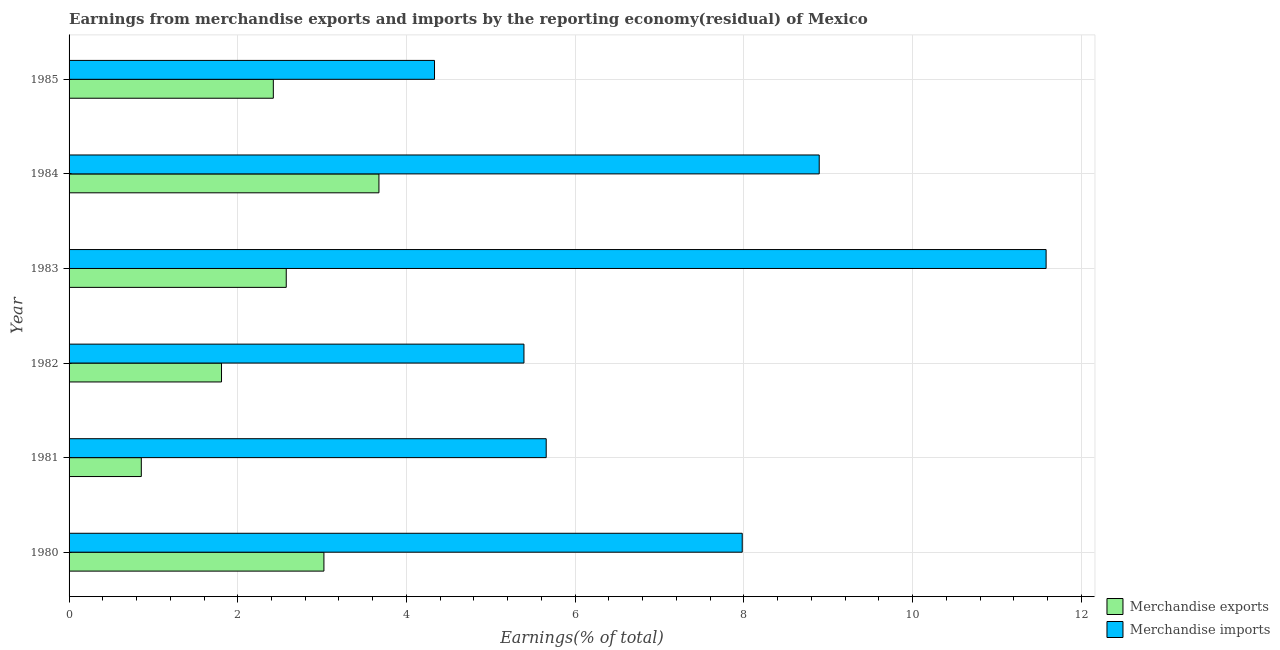How many different coloured bars are there?
Your answer should be very brief. 2. Are the number of bars on each tick of the Y-axis equal?
Make the answer very short. Yes. How many bars are there on the 6th tick from the top?
Give a very brief answer. 2. In how many cases, is the number of bars for a given year not equal to the number of legend labels?
Your answer should be very brief. 0. What is the earnings from merchandise imports in 1980?
Give a very brief answer. 7.98. Across all years, what is the maximum earnings from merchandise imports?
Your answer should be very brief. 11.58. Across all years, what is the minimum earnings from merchandise exports?
Ensure brevity in your answer.  0.86. In which year was the earnings from merchandise imports maximum?
Your answer should be very brief. 1983. What is the total earnings from merchandise exports in the graph?
Provide a succinct answer. 14.36. What is the difference between the earnings from merchandise imports in 1982 and that in 1984?
Your answer should be very brief. -3.5. What is the difference between the earnings from merchandise imports in 1984 and the earnings from merchandise exports in 1983?
Your answer should be compact. 6.32. What is the average earnings from merchandise exports per year?
Offer a very short reply. 2.39. In the year 1983, what is the difference between the earnings from merchandise exports and earnings from merchandise imports?
Your answer should be compact. -9.01. In how many years, is the earnings from merchandise exports greater than 5.2 %?
Ensure brevity in your answer.  0. What is the ratio of the earnings from merchandise imports in 1984 to that in 1985?
Offer a very short reply. 2.05. What is the difference between the highest and the second highest earnings from merchandise exports?
Make the answer very short. 0.65. What is the difference between the highest and the lowest earnings from merchandise exports?
Offer a terse response. 2.82. What does the 2nd bar from the top in 1982 represents?
Offer a very short reply. Merchandise exports. What does the 2nd bar from the bottom in 1984 represents?
Offer a terse response. Merchandise imports. How many bars are there?
Give a very brief answer. 12. Are all the bars in the graph horizontal?
Offer a very short reply. Yes. What is the difference between two consecutive major ticks on the X-axis?
Provide a succinct answer. 2. Are the values on the major ticks of X-axis written in scientific E-notation?
Ensure brevity in your answer.  No. Does the graph contain grids?
Your answer should be very brief. Yes. How are the legend labels stacked?
Make the answer very short. Vertical. What is the title of the graph?
Offer a terse response. Earnings from merchandise exports and imports by the reporting economy(residual) of Mexico. Does "Urban Population" appear as one of the legend labels in the graph?
Your response must be concise. No. What is the label or title of the X-axis?
Ensure brevity in your answer.  Earnings(% of total). What is the label or title of the Y-axis?
Your response must be concise. Year. What is the Earnings(% of total) of Merchandise exports in 1980?
Make the answer very short. 3.02. What is the Earnings(% of total) in Merchandise imports in 1980?
Offer a very short reply. 7.98. What is the Earnings(% of total) in Merchandise exports in 1981?
Give a very brief answer. 0.86. What is the Earnings(% of total) in Merchandise imports in 1981?
Provide a succinct answer. 5.66. What is the Earnings(% of total) in Merchandise exports in 1982?
Give a very brief answer. 1.81. What is the Earnings(% of total) of Merchandise imports in 1982?
Offer a terse response. 5.39. What is the Earnings(% of total) in Merchandise exports in 1983?
Offer a terse response. 2.57. What is the Earnings(% of total) of Merchandise imports in 1983?
Keep it short and to the point. 11.58. What is the Earnings(% of total) in Merchandise exports in 1984?
Offer a terse response. 3.67. What is the Earnings(% of total) of Merchandise imports in 1984?
Offer a very short reply. 8.89. What is the Earnings(% of total) in Merchandise exports in 1985?
Your response must be concise. 2.42. What is the Earnings(% of total) in Merchandise imports in 1985?
Offer a very short reply. 4.33. Across all years, what is the maximum Earnings(% of total) in Merchandise exports?
Your answer should be very brief. 3.67. Across all years, what is the maximum Earnings(% of total) in Merchandise imports?
Your answer should be compact. 11.58. Across all years, what is the minimum Earnings(% of total) of Merchandise exports?
Provide a succinct answer. 0.86. Across all years, what is the minimum Earnings(% of total) of Merchandise imports?
Your response must be concise. 4.33. What is the total Earnings(% of total) of Merchandise exports in the graph?
Ensure brevity in your answer.  14.36. What is the total Earnings(% of total) in Merchandise imports in the graph?
Your answer should be compact. 43.84. What is the difference between the Earnings(% of total) in Merchandise exports in 1980 and that in 1981?
Keep it short and to the point. 2.16. What is the difference between the Earnings(% of total) in Merchandise imports in 1980 and that in 1981?
Keep it short and to the point. 2.32. What is the difference between the Earnings(% of total) in Merchandise exports in 1980 and that in 1982?
Offer a very short reply. 1.21. What is the difference between the Earnings(% of total) in Merchandise imports in 1980 and that in 1982?
Offer a very short reply. 2.59. What is the difference between the Earnings(% of total) in Merchandise exports in 1980 and that in 1983?
Make the answer very short. 0.45. What is the difference between the Earnings(% of total) of Merchandise imports in 1980 and that in 1983?
Offer a terse response. -3.6. What is the difference between the Earnings(% of total) of Merchandise exports in 1980 and that in 1984?
Your response must be concise. -0.65. What is the difference between the Earnings(% of total) in Merchandise imports in 1980 and that in 1984?
Provide a succinct answer. -0.91. What is the difference between the Earnings(% of total) of Merchandise exports in 1980 and that in 1985?
Offer a terse response. 0.6. What is the difference between the Earnings(% of total) of Merchandise imports in 1980 and that in 1985?
Your answer should be compact. 3.65. What is the difference between the Earnings(% of total) of Merchandise exports in 1981 and that in 1982?
Offer a very short reply. -0.95. What is the difference between the Earnings(% of total) of Merchandise imports in 1981 and that in 1982?
Provide a succinct answer. 0.26. What is the difference between the Earnings(% of total) of Merchandise exports in 1981 and that in 1983?
Keep it short and to the point. -1.72. What is the difference between the Earnings(% of total) of Merchandise imports in 1981 and that in 1983?
Offer a terse response. -5.93. What is the difference between the Earnings(% of total) in Merchandise exports in 1981 and that in 1984?
Ensure brevity in your answer.  -2.82. What is the difference between the Earnings(% of total) of Merchandise imports in 1981 and that in 1984?
Offer a terse response. -3.24. What is the difference between the Earnings(% of total) of Merchandise exports in 1981 and that in 1985?
Your answer should be compact. -1.56. What is the difference between the Earnings(% of total) in Merchandise imports in 1981 and that in 1985?
Keep it short and to the point. 1.32. What is the difference between the Earnings(% of total) in Merchandise exports in 1982 and that in 1983?
Keep it short and to the point. -0.77. What is the difference between the Earnings(% of total) of Merchandise imports in 1982 and that in 1983?
Make the answer very short. -6.19. What is the difference between the Earnings(% of total) in Merchandise exports in 1982 and that in 1984?
Ensure brevity in your answer.  -1.87. What is the difference between the Earnings(% of total) in Merchandise imports in 1982 and that in 1984?
Provide a short and direct response. -3.5. What is the difference between the Earnings(% of total) of Merchandise exports in 1982 and that in 1985?
Offer a terse response. -0.61. What is the difference between the Earnings(% of total) of Merchandise imports in 1982 and that in 1985?
Provide a succinct answer. 1.06. What is the difference between the Earnings(% of total) of Merchandise exports in 1983 and that in 1984?
Ensure brevity in your answer.  -1.1. What is the difference between the Earnings(% of total) in Merchandise imports in 1983 and that in 1984?
Give a very brief answer. 2.69. What is the difference between the Earnings(% of total) in Merchandise exports in 1983 and that in 1985?
Provide a short and direct response. 0.15. What is the difference between the Earnings(% of total) in Merchandise imports in 1983 and that in 1985?
Your response must be concise. 7.25. What is the difference between the Earnings(% of total) of Merchandise exports in 1984 and that in 1985?
Keep it short and to the point. 1.25. What is the difference between the Earnings(% of total) in Merchandise imports in 1984 and that in 1985?
Make the answer very short. 4.56. What is the difference between the Earnings(% of total) of Merchandise exports in 1980 and the Earnings(% of total) of Merchandise imports in 1981?
Your answer should be very brief. -2.64. What is the difference between the Earnings(% of total) in Merchandise exports in 1980 and the Earnings(% of total) in Merchandise imports in 1982?
Provide a succinct answer. -2.37. What is the difference between the Earnings(% of total) of Merchandise exports in 1980 and the Earnings(% of total) of Merchandise imports in 1983?
Offer a terse response. -8.56. What is the difference between the Earnings(% of total) in Merchandise exports in 1980 and the Earnings(% of total) in Merchandise imports in 1984?
Your answer should be compact. -5.87. What is the difference between the Earnings(% of total) of Merchandise exports in 1980 and the Earnings(% of total) of Merchandise imports in 1985?
Your answer should be compact. -1.31. What is the difference between the Earnings(% of total) in Merchandise exports in 1981 and the Earnings(% of total) in Merchandise imports in 1982?
Your response must be concise. -4.54. What is the difference between the Earnings(% of total) of Merchandise exports in 1981 and the Earnings(% of total) of Merchandise imports in 1983?
Your answer should be very brief. -10.73. What is the difference between the Earnings(% of total) of Merchandise exports in 1981 and the Earnings(% of total) of Merchandise imports in 1984?
Provide a succinct answer. -8.04. What is the difference between the Earnings(% of total) of Merchandise exports in 1981 and the Earnings(% of total) of Merchandise imports in 1985?
Keep it short and to the point. -3.48. What is the difference between the Earnings(% of total) of Merchandise exports in 1982 and the Earnings(% of total) of Merchandise imports in 1983?
Make the answer very short. -9.78. What is the difference between the Earnings(% of total) of Merchandise exports in 1982 and the Earnings(% of total) of Merchandise imports in 1984?
Your answer should be compact. -7.09. What is the difference between the Earnings(% of total) of Merchandise exports in 1982 and the Earnings(% of total) of Merchandise imports in 1985?
Keep it short and to the point. -2.53. What is the difference between the Earnings(% of total) in Merchandise exports in 1983 and the Earnings(% of total) in Merchandise imports in 1984?
Offer a terse response. -6.32. What is the difference between the Earnings(% of total) of Merchandise exports in 1983 and the Earnings(% of total) of Merchandise imports in 1985?
Your answer should be very brief. -1.76. What is the difference between the Earnings(% of total) in Merchandise exports in 1984 and the Earnings(% of total) in Merchandise imports in 1985?
Make the answer very short. -0.66. What is the average Earnings(% of total) of Merchandise exports per year?
Offer a very short reply. 2.39. What is the average Earnings(% of total) in Merchandise imports per year?
Give a very brief answer. 7.31. In the year 1980, what is the difference between the Earnings(% of total) in Merchandise exports and Earnings(% of total) in Merchandise imports?
Make the answer very short. -4.96. In the year 1982, what is the difference between the Earnings(% of total) of Merchandise exports and Earnings(% of total) of Merchandise imports?
Ensure brevity in your answer.  -3.59. In the year 1983, what is the difference between the Earnings(% of total) of Merchandise exports and Earnings(% of total) of Merchandise imports?
Keep it short and to the point. -9.01. In the year 1984, what is the difference between the Earnings(% of total) in Merchandise exports and Earnings(% of total) in Merchandise imports?
Provide a short and direct response. -5.22. In the year 1985, what is the difference between the Earnings(% of total) of Merchandise exports and Earnings(% of total) of Merchandise imports?
Provide a short and direct response. -1.91. What is the ratio of the Earnings(% of total) of Merchandise exports in 1980 to that in 1981?
Your answer should be very brief. 3.53. What is the ratio of the Earnings(% of total) of Merchandise imports in 1980 to that in 1981?
Give a very brief answer. 1.41. What is the ratio of the Earnings(% of total) of Merchandise exports in 1980 to that in 1982?
Your answer should be compact. 1.67. What is the ratio of the Earnings(% of total) in Merchandise imports in 1980 to that in 1982?
Provide a succinct answer. 1.48. What is the ratio of the Earnings(% of total) of Merchandise exports in 1980 to that in 1983?
Offer a terse response. 1.17. What is the ratio of the Earnings(% of total) of Merchandise imports in 1980 to that in 1983?
Provide a short and direct response. 0.69. What is the ratio of the Earnings(% of total) in Merchandise exports in 1980 to that in 1984?
Give a very brief answer. 0.82. What is the ratio of the Earnings(% of total) in Merchandise imports in 1980 to that in 1984?
Your answer should be very brief. 0.9. What is the ratio of the Earnings(% of total) in Merchandise exports in 1980 to that in 1985?
Your response must be concise. 1.25. What is the ratio of the Earnings(% of total) in Merchandise imports in 1980 to that in 1985?
Make the answer very short. 1.84. What is the ratio of the Earnings(% of total) in Merchandise exports in 1981 to that in 1982?
Make the answer very short. 0.47. What is the ratio of the Earnings(% of total) in Merchandise imports in 1981 to that in 1982?
Ensure brevity in your answer.  1.05. What is the ratio of the Earnings(% of total) in Merchandise exports in 1981 to that in 1983?
Provide a succinct answer. 0.33. What is the ratio of the Earnings(% of total) of Merchandise imports in 1981 to that in 1983?
Your answer should be compact. 0.49. What is the ratio of the Earnings(% of total) in Merchandise exports in 1981 to that in 1984?
Provide a short and direct response. 0.23. What is the ratio of the Earnings(% of total) in Merchandise imports in 1981 to that in 1984?
Give a very brief answer. 0.64. What is the ratio of the Earnings(% of total) of Merchandise exports in 1981 to that in 1985?
Offer a terse response. 0.35. What is the ratio of the Earnings(% of total) in Merchandise imports in 1981 to that in 1985?
Your response must be concise. 1.31. What is the ratio of the Earnings(% of total) in Merchandise exports in 1982 to that in 1983?
Make the answer very short. 0.7. What is the ratio of the Earnings(% of total) of Merchandise imports in 1982 to that in 1983?
Your response must be concise. 0.47. What is the ratio of the Earnings(% of total) of Merchandise exports in 1982 to that in 1984?
Offer a terse response. 0.49. What is the ratio of the Earnings(% of total) of Merchandise imports in 1982 to that in 1984?
Provide a short and direct response. 0.61. What is the ratio of the Earnings(% of total) in Merchandise exports in 1982 to that in 1985?
Provide a succinct answer. 0.75. What is the ratio of the Earnings(% of total) in Merchandise imports in 1982 to that in 1985?
Keep it short and to the point. 1.24. What is the ratio of the Earnings(% of total) of Merchandise exports in 1983 to that in 1984?
Your response must be concise. 0.7. What is the ratio of the Earnings(% of total) in Merchandise imports in 1983 to that in 1984?
Provide a short and direct response. 1.3. What is the ratio of the Earnings(% of total) of Merchandise exports in 1983 to that in 1985?
Offer a very short reply. 1.06. What is the ratio of the Earnings(% of total) in Merchandise imports in 1983 to that in 1985?
Give a very brief answer. 2.67. What is the ratio of the Earnings(% of total) of Merchandise exports in 1984 to that in 1985?
Provide a short and direct response. 1.52. What is the ratio of the Earnings(% of total) in Merchandise imports in 1984 to that in 1985?
Provide a succinct answer. 2.05. What is the difference between the highest and the second highest Earnings(% of total) in Merchandise exports?
Give a very brief answer. 0.65. What is the difference between the highest and the second highest Earnings(% of total) in Merchandise imports?
Make the answer very short. 2.69. What is the difference between the highest and the lowest Earnings(% of total) in Merchandise exports?
Ensure brevity in your answer.  2.82. What is the difference between the highest and the lowest Earnings(% of total) of Merchandise imports?
Your response must be concise. 7.25. 